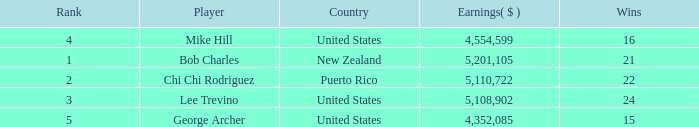What is the lowest level of Earnings($) to have a Wins value of 22 and a Rank lower than 2? None. 